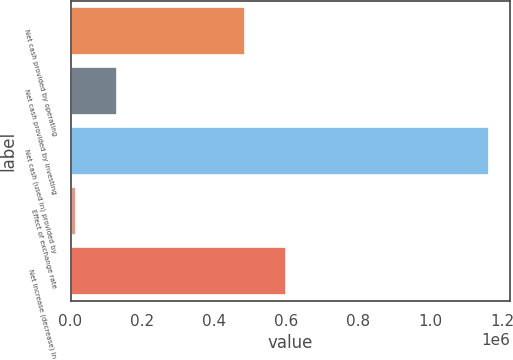<chart> <loc_0><loc_0><loc_500><loc_500><bar_chart><fcel>Net cash provided by operating<fcel>Net cash provided by investing<fcel>Net cash (used in) provided by<fcel>Effect of exchange rate<fcel>Net increase (decrease) in<nl><fcel>484034<fcel>130420<fcel>1.16403e+06<fcel>15575<fcel>598879<nl></chart> 